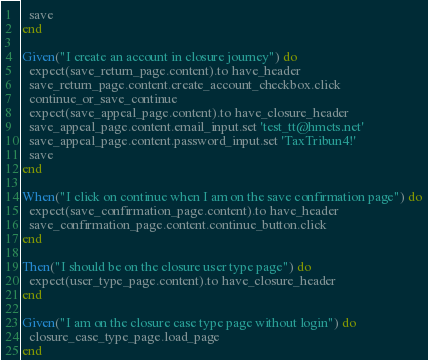Convert code to text. <code><loc_0><loc_0><loc_500><loc_500><_Ruby_>  save
end

Given("I create an account in closure journey") do
  expect(save_return_page.content).to have_header
  save_return_page.content.create_account_checkbox.click
  continue_or_save_continue
  expect(save_appeal_page.content).to have_closure_header
  save_appeal_page.content.email_input.set 'test_tt@hmcts.net'
  save_appeal_page.content.password_input.set 'TaxTribun4!'
  save
end

When("I click on continue when I am on the save confirmation page") do
  expect(save_confirmation_page.content).to have_header
  save_confirmation_page.content.continue_button.click
end

Then("I should be on the closure user type page") do
  expect(user_type_page.content).to have_closure_header
end

Given("I am on the closure case type page without login") do
  closure_case_type_page.load_page
end
</code> 